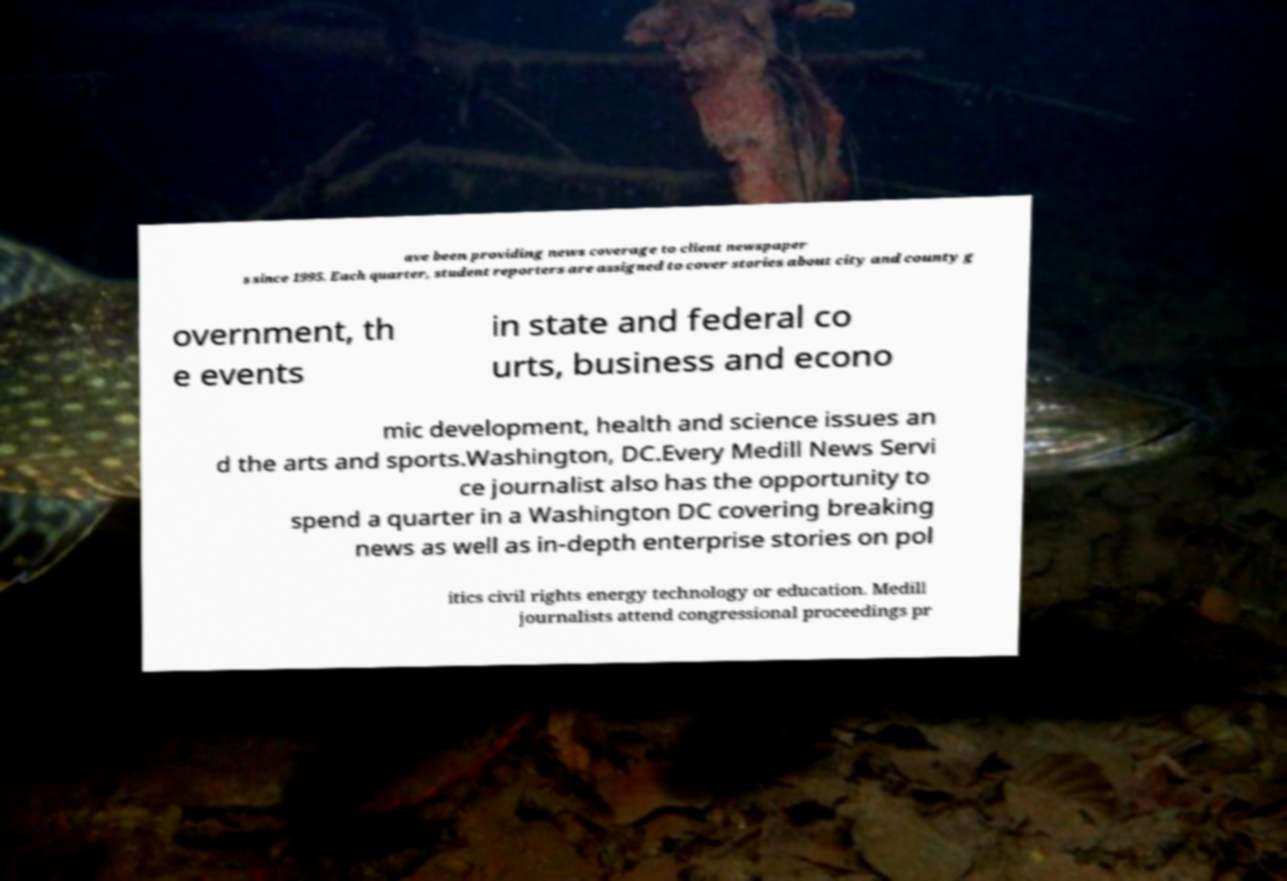For documentation purposes, I need the text within this image transcribed. Could you provide that? ave been providing news coverage to client newspaper s since 1995. Each quarter, student reporters are assigned to cover stories about city and county g overnment, th e events in state and federal co urts, business and econo mic development, health and science issues an d the arts and sports.Washington, DC.Every Medill News Servi ce journalist also has the opportunity to spend a quarter in a Washington DC covering breaking news as well as in-depth enterprise stories on pol itics civil rights energy technology or education. Medill journalists attend congressional proceedings pr 